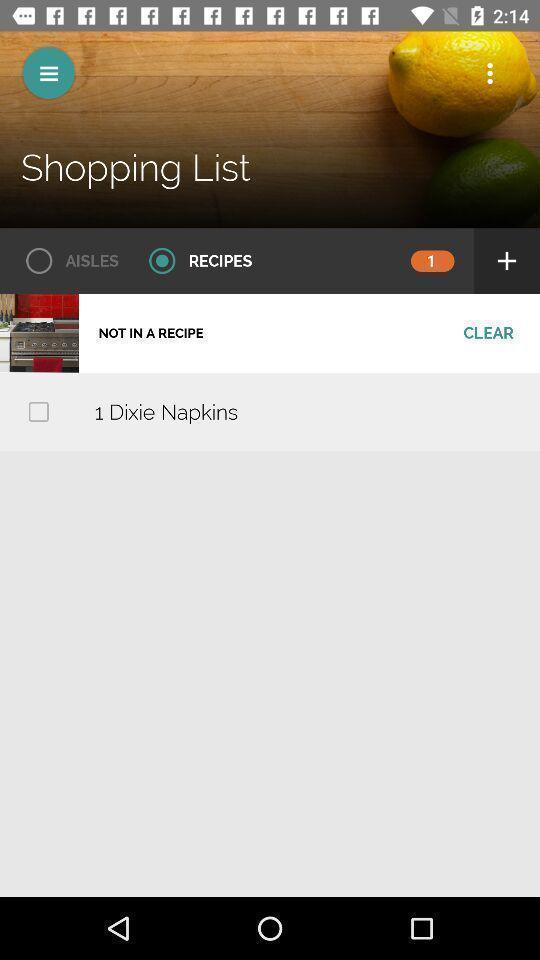Describe the content in this image. Screen page of an shopping app. 